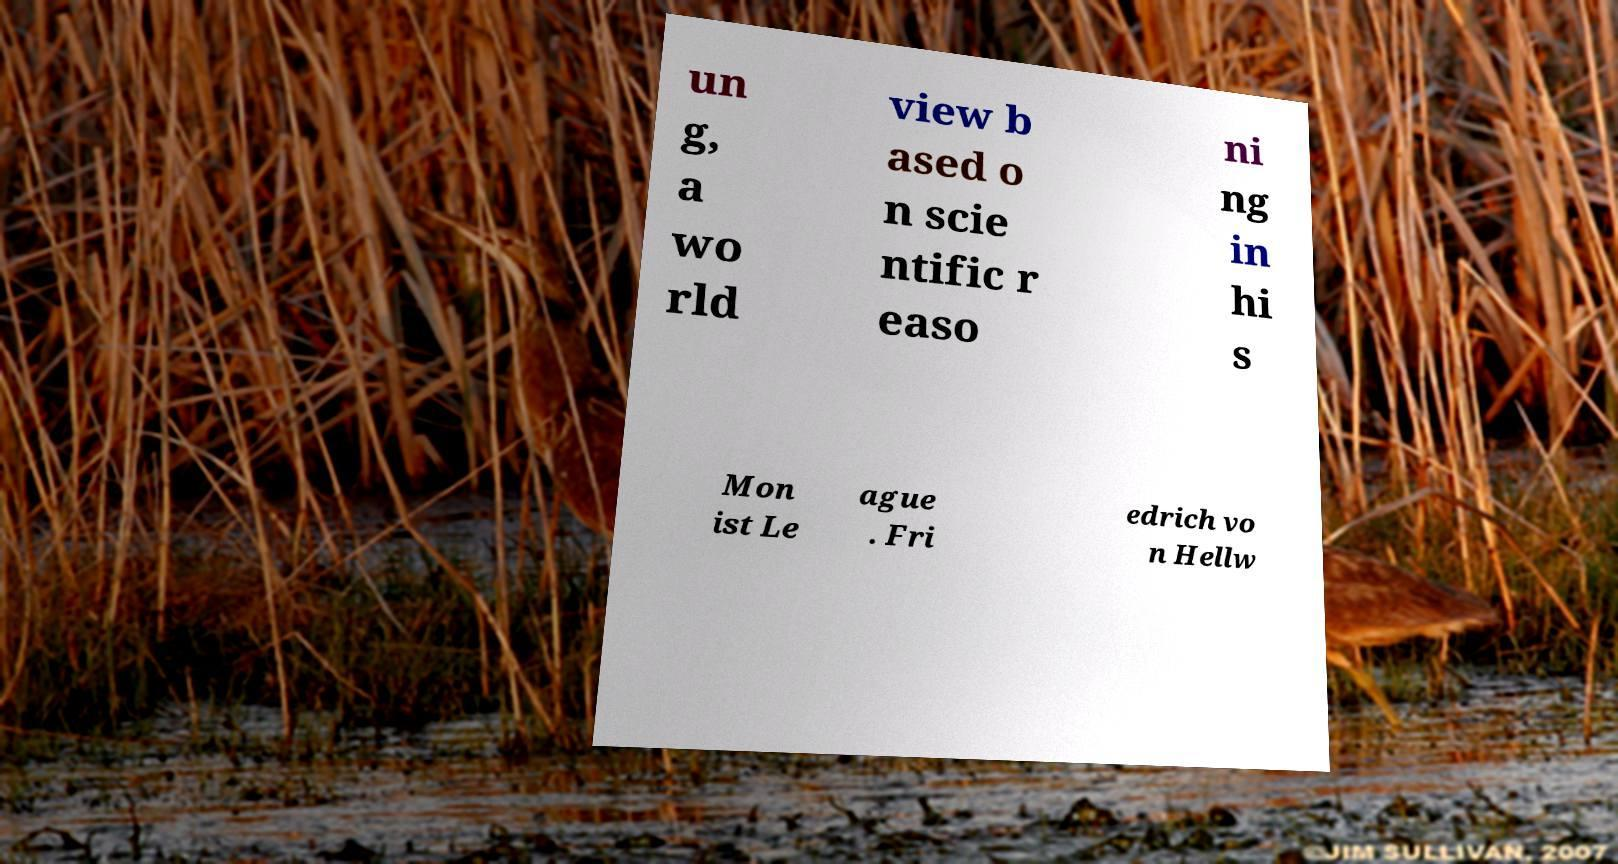For documentation purposes, I need the text within this image transcribed. Could you provide that? un g, a wo rld view b ased o n scie ntific r easo ni ng in hi s Mon ist Le ague . Fri edrich vo n Hellw 